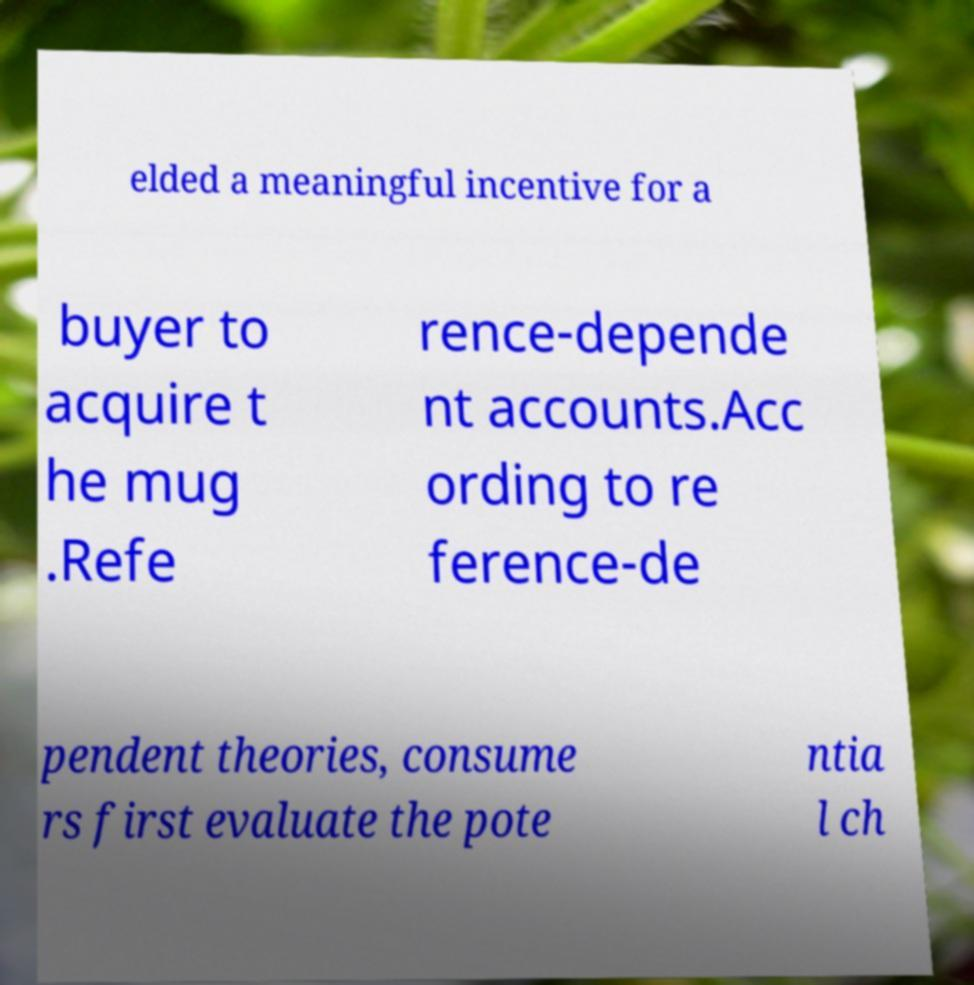Could you extract and type out the text from this image? elded a meaningful incentive for a buyer to acquire t he mug .Refe rence-depende nt accounts.Acc ording to re ference-de pendent theories, consume rs first evaluate the pote ntia l ch 